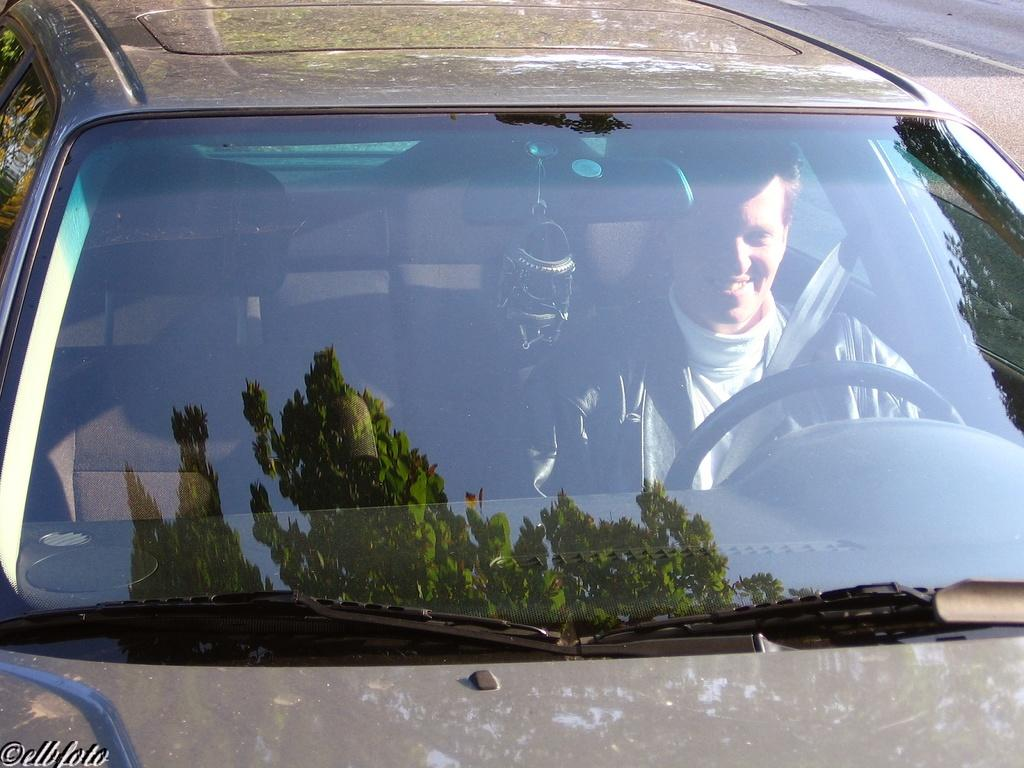What is the main subject of the image? The main subject of the image is a car. Is there anyone inside the car? Yes, there is a man in the car. How is the man in the car feeling? The man is smiling, which suggests he is happy or content. What type of seed can be seen growing in the car? There is no seed present in the car; it is a man sitting inside a car. How many pears are visible on the dashboard of the car? There are no pears visible in the car; the image only shows a man inside the car. 